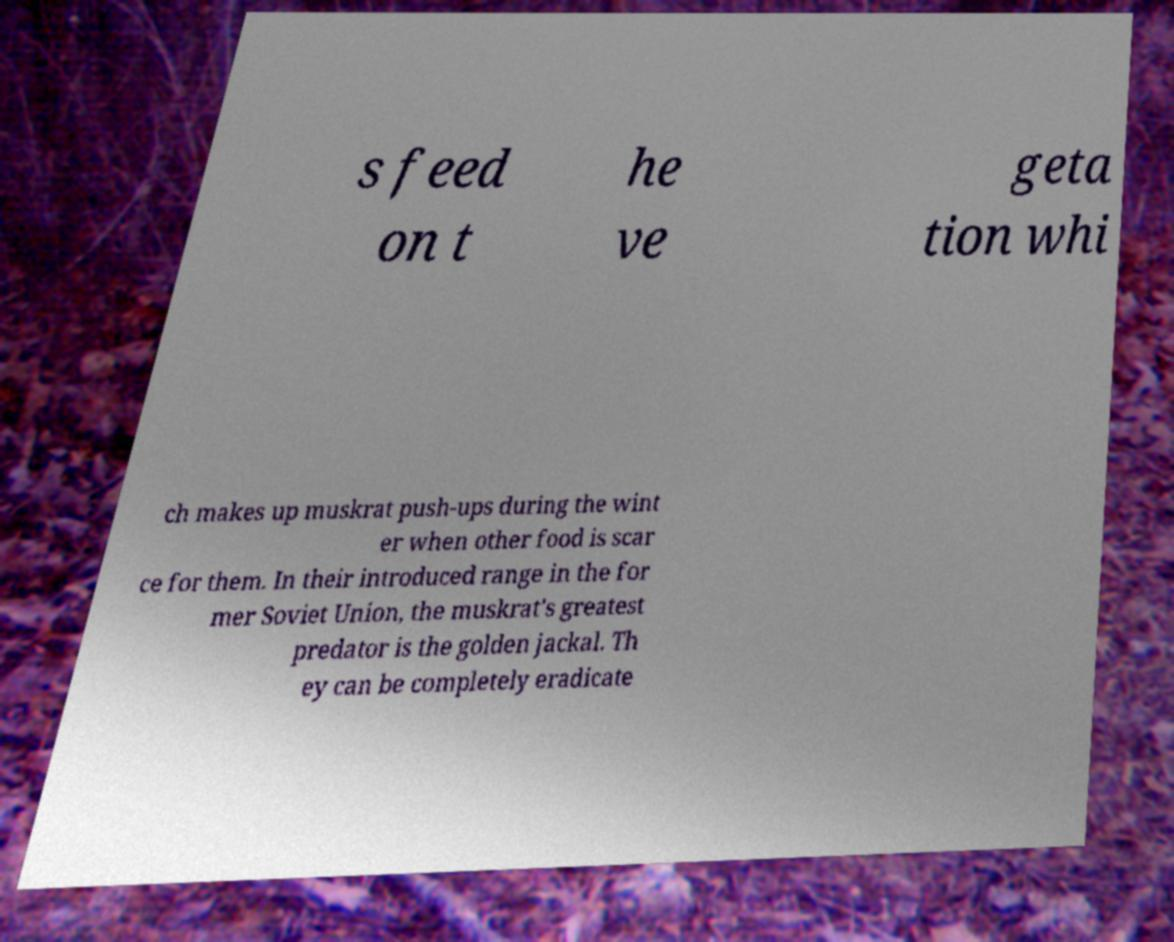What messages or text are displayed in this image? I need them in a readable, typed format. s feed on t he ve geta tion whi ch makes up muskrat push-ups during the wint er when other food is scar ce for them. In their introduced range in the for mer Soviet Union, the muskrat's greatest predator is the golden jackal. Th ey can be completely eradicate 